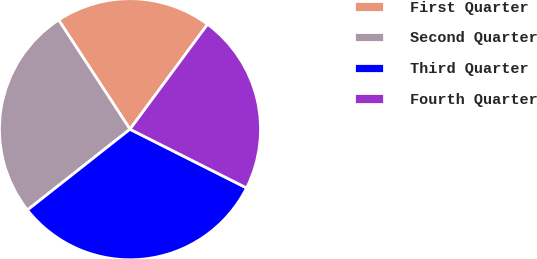<chart> <loc_0><loc_0><loc_500><loc_500><pie_chart><fcel>First Quarter<fcel>Second Quarter<fcel>Third Quarter<fcel>Fourth Quarter<nl><fcel>19.34%<fcel>26.41%<fcel>31.96%<fcel>22.29%<nl></chart> 